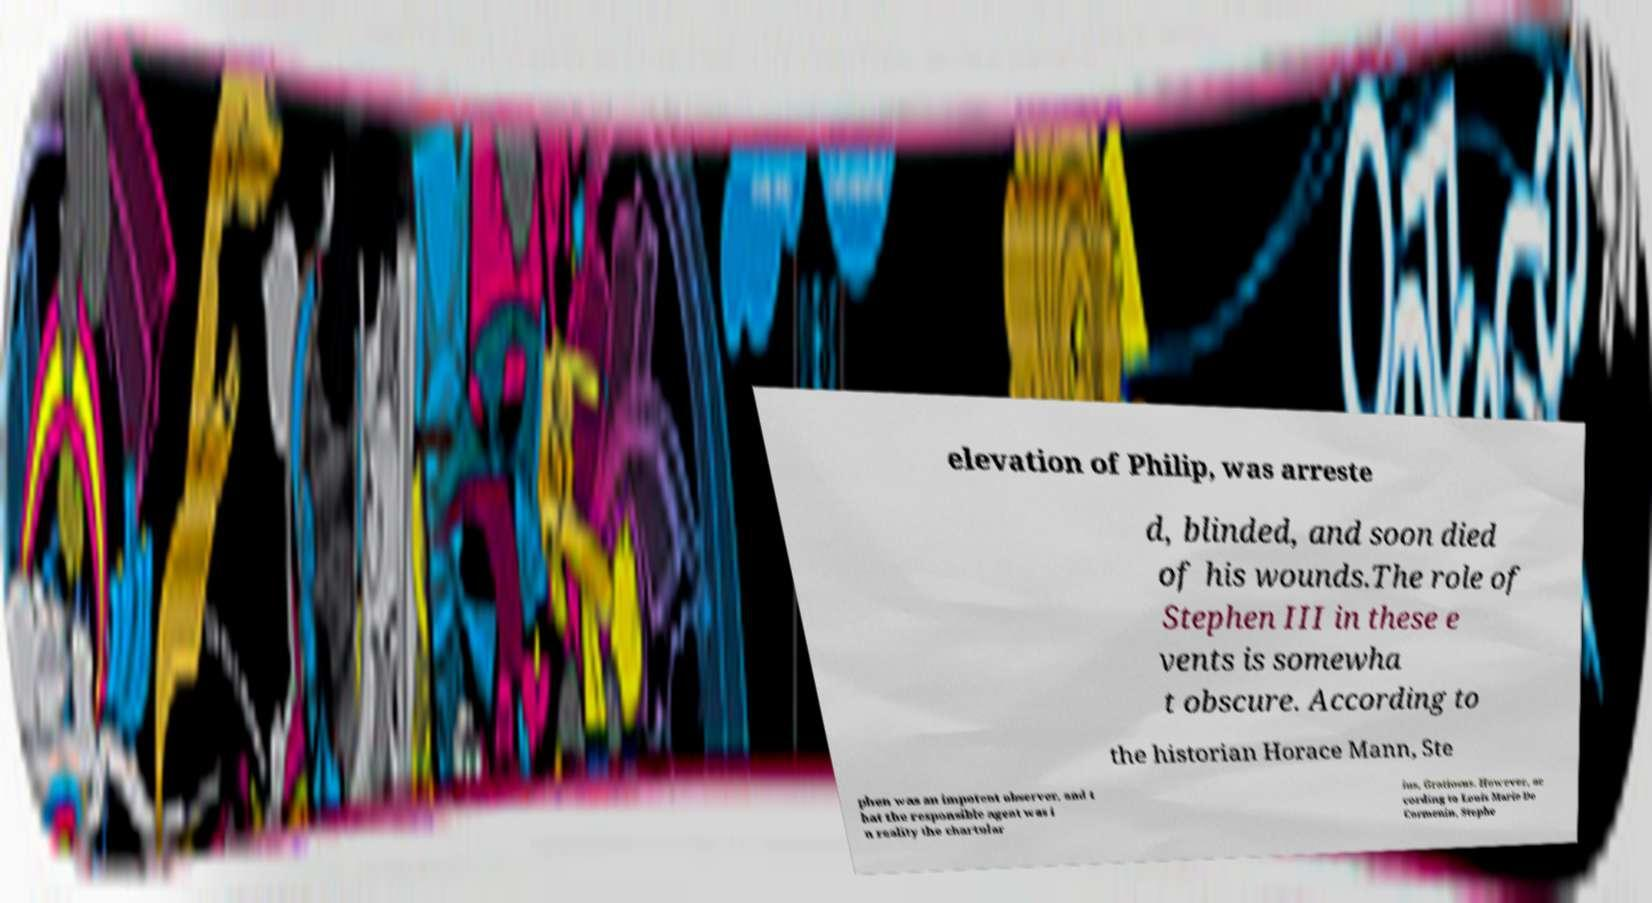Please identify and transcribe the text found in this image. elevation of Philip, was arreste d, blinded, and soon died of his wounds.The role of Stephen III in these e vents is somewha t obscure. According to the historian Horace Mann, Ste phen was an impotent observer, and t hat the responsible agent was i n reality the chartular ius, Gratiosus. However, ac cording to Louis Marie De Cormenin, Stephe 